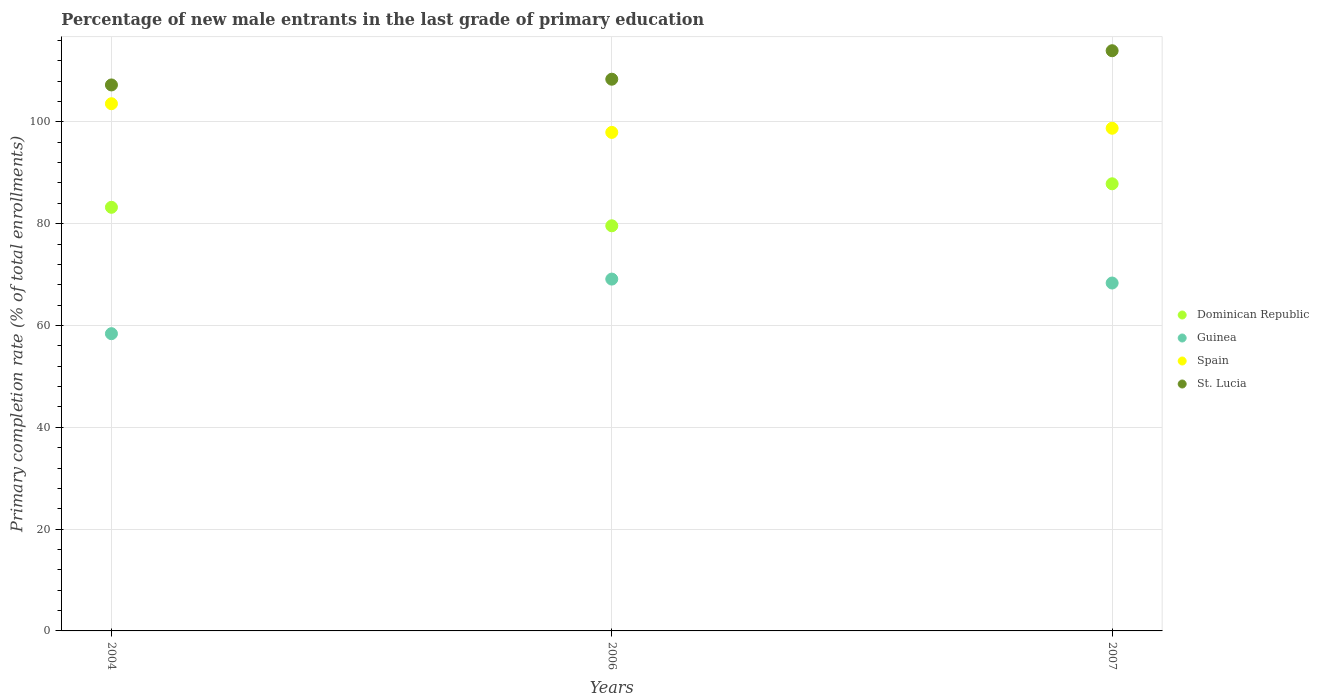What is the percentage of new male entrants in Dominican Republic in 2004?
Your answer should be very brief. 83.22. Across all years, what is the maximum percentage of new male entrants in Guinea?
Provide a short and direct response. 69.12. Across all years, what is the minimum percentage of new male entrants in Guinea?
Ensure brevity in your answer.  58.39. What is the total percentage of new male entrants in Guinea in the graph?
Your answer should be compact. 195.85. What is the difference between the percentage of new male entrants in Spain in 2006 and that in 2007?
Provide a short and direct response. -0.82. What is the difference between the percentage of new male entrants in Spain in 2006 and the percentage of new male entrants in St. Lucia in 2004?
Offer a terse response. -9.32. What is the average percentage of new male entrants in Spain per year?
Provide a short and direct response. 100.08. In the year 2006, what is the difference between the percentage of new male entrants in Guinea and percentage of new male entrants in Dominican Republic?
Offer a terse response. -10.47. What is the ratio of the percentage of new male entrants in Guinea in 2006 to that in 2007?
Ensure brevity in your answer.  1.01. What is the difference between the highest and the second highest percentage of new male entrants in Dominican Republic?
Give a very brief answer. 4.62. What is the difference between the highest and the lowest percentage of new male entrants in St. Lucia?
Provide a succinct answer. 6.72. In how many years, is the percentage of new male entrants in Spain greater than the average percentage of new male entrants in Spain taken over all years?
Ensure brevity in your answer.  1. Is the sum of the percentage of new male entrants in St. Lucia in 2004 and 2006 greater than the maximum percentage of new male entrants in Dominican Republic across all years?
Your response must be concise. Yes. Is the percentage of new male entrants in Dominican Republic strictly greater than the percentage of new male entrants in Spain over the years?
Offer a terse response. No. Is the percentage of new male entrants in St. Lucia strictly less than the percentage of new male entrants in Spain over the years?
Provide a succinct answer. No. How are the legend labels stacked?
Keep it short and to the point. Vertical. What is the title of the graph?
Ensure brevity in your answer.  Percentage of new male entrants in the last grade of primary education. Does "High income" appear as one of the legend labels in the graph?
Give a very brief answer. No. What is the label or title of the Y-axis?
Ensure brevity in your answer.  Primary completion rate (% of total enrollments). What is the Primary completion rate (% of total enrollments) in Dominican Republic in 2004?
Give a very brief answer. 83.22. What is the Primary completion rate (% of total enrollments) of Guinea in 2004?
Provide a short and direct response. 58.39. What is the Primary completion rate (% of total enrollments) in Spain in 2004?
Offer a terse response. 103.57. What is the Primary completion rate (% of total enrollments) in St. Lucia in 2004?
Keep it short and to the point. 107.26. What is the Primary completion rate (% of total enrollments) of Dominican Republic in 2006?
Give a very brief answer. 79.59. What is the Primary completion rate (% of total enrollments) in Guinea in 2006?
Give a very brief answer. 69.12. What is the Primary completion rate (% of total enrollments) in Spain in 2006?
Your answer should be compact. 97.93. What is the Primary completion rate (% of total enrollments) of St. Lucia in 2006?
Your answer should be very brief. 108.38. What is the Primary completion rate (% of total enrollments) of Dominican Republic in 2007?
Offer a very short reply. 87.84. What is the Primary completion rate (% of total enrollments) in Guinea in 2007?
Your response must be concise. 68.34. What is the Primary completion rate (% of total enrollments) of Spain in 2007?
Your answer should be compact. 98.75. What is the Primary completion rate (% of total enrollments) of St. Lucia in 2007?
Provide a short and direct response. 113.98. Across all years, what is the maximum Primary completion rate (% of total enrollments) of Dominican Republic?
Your answer should be very brief. 87.84. Across all years, what is the maximum Primary completion rate (% of total enrollments) in Guinea?
Make the answer very short. 69.12. Across all years, what is the maximum Primary completion rate (% of total enrollments) of Spain?
Keep it short and to the point. 103.57. Across all years, what is the maximum Primary completion rate (% of total enrollments) of St. Lucia?
Keep it short and to the point. 113.98. Across all years, what is the minimum Primary completion rate (% of total enrollments) of Dominican Republic?
Ensure brevity in your answer.  79.59. Across all years, what is the minimum Primary completion rate (% of total enrollments) in Guinea?
Provide a short and direct response. 58.39. Across all years, what is the minimum Primary completion rate (% of total enrollments) in Spain?
Your answer should be compact. 97.93. Across all years, what is the minimum Primary completion rate (% of total enrollments) of St. Lucia?
Keep it short and to the point. 107.26. What is the total Primary completion rate (% of total enrollments) in Dominican Republic in the graph?
Your response must be concise. 250.65. What is the total Primary completion rate (% of total enrollments) of Guinea in the graph?
Make the answer very short. 195.85. What is the total Primary completion rate (% of total enrollments) in Spain in the graph?
Ensure brevity in your answer.  300.25. What is the total Primary completion rate (% of total enrollments) in St. Lucia in the graph?
Provide a short and direct response. 329.62. What is the difference between the Primary completion rate (% of total enrollments) in Dominican Republic in 2004 and that in 2006?
Your response must be concise. 3.63. What is the difference between the Primary completion rate (% of total enrollments) in Guinea in 2004 and that in 2006?
Ensure brevity in your answer.  -10.72. What is the difference between the Primary completion rate (% of total enrollments) in Spain in 2004 and that in 2006?
Offer a terse response. 5.63. What is the difference between the Primary completion rate (% of total enrollments) of St. Lucia in 2004 and that in 2006?
Provide a succinct answer. -1.12. What is the difference between the Primary completion rate (% of total enrollments) of Dominican Republic in 2004 and that in 2007?
Provide a short and direct response. -4.62. What is the difference between the Primary completion rate (% of total enrollments) of Guinea in 2004 and that in 2007?
Offer a terse response. -9.95. What is the difference between the Primary completion rate (% of total enrollments) in Spain in 2004 and that in 2007?
Give a very brief answer. 4.82. What is the difference between the Primary completion rate (% of total enrollments) of St. Lucia in 2004 and that in 2007?
Ensure brevity in your answer.  -6.72. What is the difference between the Primary completion rate (% of total enrollments) of Dominican Republic in 2006 and that in 2007?
Give a very brief answer. -8.25. What is the difference between the Primary completion rate (% of total enrollments) in Guinea in 2006 and that in 2007?
Your answer should be very brief. 0.77. What is the difference between the Primary completion rate (% of total enrollments) in Spain in 2006 and that in 2007?
Offer a terse response. -0.82. What is the difference between the Primary completion rate (% of total enrollments) of St. Lucia in 2006 and that in 2007?
Your response must be concise. -5.6. What is the difference between the Primary completion rate (% of total enrollments) of Dominican Republic in 2004 and the Primary completion rate (% of total enrollments) of Guinea in 2006?
Your answer should be compact. 14.1. What is the difference between the Primary completion rate (% of total enrollments) in Dominican Republic in 2004 and the Primary completion rate (% of total enrollments) in Spain in 2006?
Make the answer very short. -14.71. What is the difference between the Primary completion rate (% of total enrollments) of Dominican Republic in 2004 and the Primary completion rate (% of total enrollments) of St. Lucia in 2006?
Your answer should be very brief. -25.16. What is the difference between the Primary completion rate (% of total enrollments) of Guinea in 2004 and the Primary completion rate (% of total enrollments) of Spain in 2006?
Provide a succinct answer. -39.54. What is the difference between the Primary completion rate (% of total enrollments) of Guinea in 2004 and the Primary completion rate (% of total enrollments) of St. Lucia in 2006?
Your answer should be compact. -49.99. What is the difference between the Primary completion rate (% of total enrollments) in Spain in 2004 and the Primary completion rate (% of total enrollments) in St. Lucia in 2006?
Keep it short and to the point. -4.81. What is the difference between the Primary completion rate (% of total enrollments) of Dominican Republic in 2004 and the Primary completion rate (% of total enrollments) of Guinea in 2007?
Keep it short and to the point. 14.88. What is the difference between the Primary completion rate (% of total enrollments) in Dominican Republic in 2004 and the Primary completion rate (% of total enrollments) in Spain in 2007?
Provide a succinct answer. -15.53. What is the difference between the Primary completion rate (% of total enrollments) in Dominican Republic in 2004 and the Primary completion rate (% of total enrollments) in St. Lucia in 2007?
Ensure brevity in your answer.  -30.76. What is the difference between the Primary completion rate (% of total enrollments) in Guinea in 2004 and the Primary completion rate (% of total enrollments) in Spain in 2007?
Offer a very short reply. -40.36. What is the difference between the Primary completion rate (% of total enrollments) of Guinea in 2004 and the Primary completion rate (% of total enrollments) of St. Lucia in 2007?
Offer a very short reply. -55.59. What is the difference between the Primary completion rate (% of total enrollments) of Spain in 2004 and the Primary completion rate (% of total enrollments) of St. Lucia in 2007?
Provide a short and direct response. -10.41. What is the difference between the Primary completion rate (% of total enrollments) in Dominican Republic in 2006 and the Primary completion rate (% of total enrollments) in Guinea in 2007?
Keep it short and to the point. 11.24. What is the difference between the Primary completion rate (% of total enrollments) in Dominican Republic in 2006 and the Primary completion rate (% of total enrollments) in Spain in 2007?
Provide a succinct answer. -19.16. What is the difference between the Primary completion rate (% of total enrollments) of Dominican Republic in 2006 and the Primary completion rate (% of total enrollments) of St. Lucia in 2007?
Offer a very short reply. -34.39. What is the difference between the Primary completion rate (% of total enrollments) in Guinea in 2006 and the Primary completion rate (% of total enrollments) in Spain in 2007?
Provide a succinct answer. -29.63. What is the difference between the Primary completion rate (% of total enrollments) of Guinea in 2006 and the Primary completion rate (% of total enrollments) of St. Lucia in 2007?
Give a very brief answer. -44.86. What is the difference between the Primary completion rate (% of total enrollments) of Spain in 2006 and the Primary completion rate (% of total enrollments) of St. Lucia in 2007?
Give a very brief answer. -16.05. What is the average Primary completion rate (% of total enrollments) of Dominican Republic per year?
Offer a terse response. 83.55. What is the average Primary completion rate (% of total enrollments) of Guinea per year?
Your response must be concise. 65.28. What is the average Primary completion rate (% of total enrollments) of Spain per year?
Offer a very short reply. 100.08. What is the average Primary completion rate (% of total enrollments) of St. Lucia per year?
Ensure brevity in your answer.  109.87. In the year 2004, what is the difference between the Primary completion rate (% of total enrollments) of Dominican Republic and Primary completion rate (% of total enrollments) of Guinea?
Your answer should be compact. 24.83. In the year 2004, what is the difference between the Primary completion rate (% of total enrollments) of Dominican Republic and Primary completion rate (% of total enrollments) of Spain?
Ensure brevity in your answer.  -20.35. In the year 2004, what is the difference between the Primary completion rate (% of total enrollments) of Dominican Republic and Primary completion rate (% of total enrollments) of St. Lucia?
Ensure brevity in your answer.  -24.04. In the year 2004, what is the difference between the Primary completion rate (% of total enrollments) in Guinea and Primary completion rate (% of total enrollments) in Spain?
Provide a short and direct response. -45.17. In the year 2004, what is the difference between the Primary completion rate (% of total enrollments) of Guinea and Primary completion rate (% of total enrollments) of St. Lucia?
Offer a terse response. -48.86. In the year 2004, what is the difference between the Primary completion rate (% of total enrollments) in Spain and Primary completion rate (% of total enrollments) in St. Lucia?
Offer a terse response. -3.69. In the year 2006, what is the difference between the Primary completion rate (% of total enrollments) of Dominican Republic and Primary completion rate (% of total enrollments) of Guinea?
Give a very brief answer. 10.47. In the year 2006, what is the difference between the Primary completion rate (% of total enrollments) of Dominican Republic and Primary completion rate (% of total enrollments) of Spain?
Your response must be concise. -18.35. In the year 2006, what is the difference between the Primary completion rate (% of total enrollments) in Dominican Republic and Primary completion rate (% of total enrollments) in St. Lucia?
Your answer should be very brief. -28.79. In the year 2006, what is the difference between the Primary completion rate (% of total enrollments) of Guinea and Primary completion rate (% of total enrollments) of Spain?
Ensure brevity in your answer.  -28.82. In the year 2006, what is the difference between the Primary completion rate (% of total enrollments) of Guinea and Primary completion rate (% of total enrollments) of St. Lucia?
Ensure brevity in your answer.  -39.27. In the year 2006, what is the difference between the Primary completion rate (% of total enrollments) in Spain and Primary completion rate (% of total enrollments) in St. Lucia?
Ensure brevity in your answer.  -10.45. In the year 2007, what is the difference between the Primary completion rate (% of total enrollments) in Dominican Republic and Primary completion rate (% of total enrollments) in Guinea?
Your answer should be compact. 19.49. In the year 2007, what is the difference between the Primary completion rate (% of total enrollments) of Dominican Republic and Primary completion rate (% of total enrollments) of Spain?
Your response must be concise. -10.91. In the year 2007, what is the difference between the Primary completion rate (% of total enrollments) in Dominican Republic and Primary completion rate (% of total enrollments) in St. Lucia?
Provide a succinct answer. -26.14. In the year 2007, what is the difference between the Primary completion rate (% of total enrollments) of Guinea and Primary completion rate (% of total enrollments) of Spain?
Provide a short and direct response. -30.41. In the year 2007, what is the difference between the Primary completion rate (% of total enrollments) in Guinea and Primary completion rate (% of total enrollments) in St. Lucia?
Your answer should be very brief. -45.63. In the year 2007, what is the difference between the Primary completion rate (% of total enrollments) in Spain and Primary completion rate (% of total enrollments) in St. Lucia?
Give a very brief answer. -15.23. What is the ratio of the Primary completion rate (% of total enrollments) in Dominican Republic in 2004 to that in 2006?
Offer a terse response. 1.05. What is the ratio of the Primary completion rate (% of total enrollments) in Guinea in 2004 to that in 2006?
Provide a short and direct response. 0.84. What is the ratio of the Primary completion rate (% of total enrollments) of Spain in 2004 to that in 2006?
Offer a terse response. 1.06. What is the ratio of the Primary completion rate (% of total enrollments) in Guinea in 2004 to that in 2007?
Provide a succinct answer. 0.85. What is the ratio of the Primary completion rate (% of total enrollments) of Spain in 2004 to that in 2007?
Provide a succinct answer. 1.05. What is the ratio of the Primary completion rate (% of total enrollments) of St. Lucia in 2004 to that in 2007?
Provide a short and direct response. 0.94. What is the ratio of the Primary completion rate (% of total enrollments) in Dominican Republic in 2006 to that in 2007?
Provide a short and direct response. 0.91. What is the ratio of the Primary completion rate (% of total enrollments) of Guinea in 2006 to that in 2007?
Your answer should be very brief. 1.01. What is the ratio of the Primary completion rate (% of total enrollments) in St. Lucia in 2006 to that in 2007?
Keep it short and to the point. 0.95. What is the difference between the highest and the second highest Primary completion rate (% of total enrollments) of Dominican Republic?
Offer a very short reply. 4.62. What is the difference between the highest and the second highest Primary completion rate (% of total enrollments) in Guinea?
Give a very brief answer. 0.77. What is the difference between the highest and the second highest Primary completion rate (% of total enrollments) of Spain?
Ensure brevity in your answer.  4.82. What is the difference between the highest and the second highest Primary completion rate (% of total enrollments) in St. Lucia?
Your answer should be very brief. 5.6. What is the difference between the highest and the lowest Primary completion rate (% of total enrollments) of Dominican Republic?
Give a very brief answer. 8.25. What is the difference between the highest and the lowest Primary completion rate (% of total enrollments) of Guinea?
Your answer should be compact. 10.72. What is the difference between the highest and the lowest Primary completion rate (% of total enrollments) in Spain?
Give a very brief answer. 5.63. What is the difference between the highest and the lowest Primary completion rate (% of total enrollments) in St. Lucia?
Your response must be concise. 6.72. 